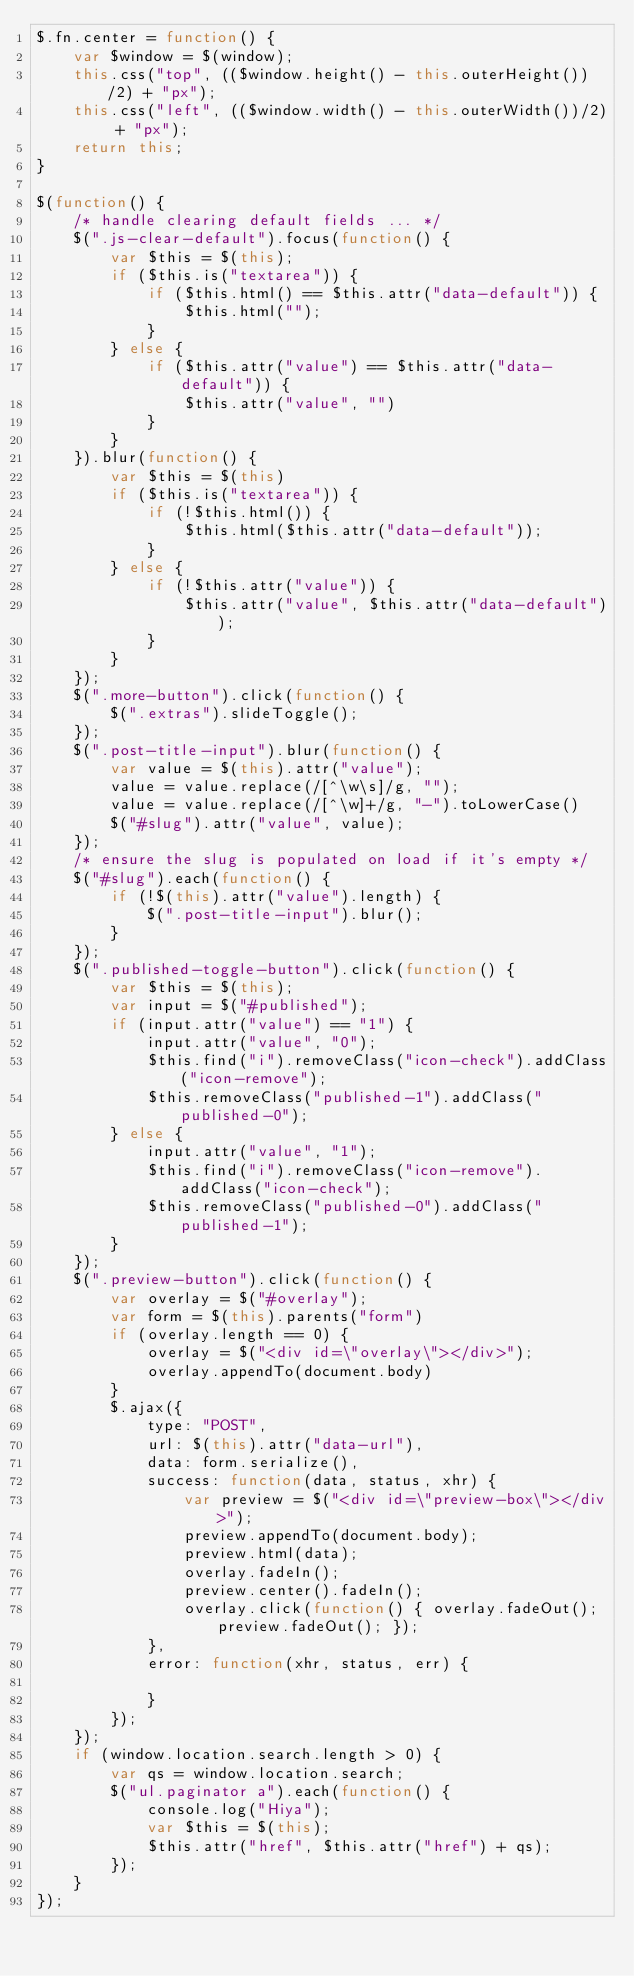<code> <loc_0><loc_0><loc_500><loc_500><_JavaScript_>$.fn.center = function() {
    var $window = $(window);
    this.css("top", (($window.height() - this.outerHeight())/2) + "px");
    this.css("left", (($window.width() - this.outerWidth())/2) + "px");
    return this;
}

$(function() {
    /* handle clearing default fields ... */
    $(".js-clear-default").focus(function() {
        var $this = $(this);
        if ($this.is("textarea")) {
            if ($this.html() == $this.attr("data-default")) {
                $this.html("");
            }
        } else {
            if ($this.attr("value") == $this.attr("data-default")) {
                $this.attr("value", "")
            }
        }
    }).blur(function() {
        var $this = $(this)
        if ($this.is("textarea")) {
            if (!$this.html()) {
                $this.html($this.attr("data-default"));
            }
        } else {
            if (!$this.attr("value")) {
                $this.attr("value", $this.attr("data-default"));
            }
        }
    });
    $(".more-button").click(function() {
        $(".extras").slideToggle();
    });
    $(".post-title-input").blur(function() {
        var value = $(this).attr("value");
        value = value.replace(/[^\w\s]/g, "");
        value = value.replace(/[^\w]+/g, "-").toLowerCase()
        $("#slug").attr("value", value);
    });
    /* ensure the slug is populated on load if it's empty */
    $("#slug").each(function() {
        if (!$(this).attr("value").length) {
            $(".post-title-input").blur();
        }
    });
    $(".published-toggle-button").click(function() {
        var $this = $(this);
        var input = $("#published");
        if (input.attr("value") == "1") {
            input.attr("value", "0");
            $this.find("i").removeClass("icon-check").addClass("icon-remove");
            $this.removeClass("published-1").addClass("published-0");
        } else {
            input.attr("value", "1");
            $this.find("i").removeClass("icon-remove").addClass("icon-check");
            $this.removeClass("published-0").addClass("published-1");
        }
    });
    $(".preview-button").click(function() {
        var overlay = $("#overlay");
        var form = $(this).parents("form")
        if (overlay.length == 0) {
            overlay = $("<div id=\"overlay\"></div>");
            overlay.appendTo(document.body)
        }
        $.ajax({
            type: "POST",
            url: $(this).attr("data-url"),
            data: form.serialize(),
            success: function(data, status, xhr) {
                var preview = $("<div id=\"preview-box\"></div>");
                preview.appendTo(document.body);
                preview.html(data);
                overlay.fadeIn();
                preview.center().fadeIn();
                overlay.click(function() { overlay.fadeOut(); preview.fadeOut(); });
            },
            error: function(xhr, status, err) {

            }
        });
    });
    if (window.location.search.length > 0) {
        var qs = window.location.search;
        $("ul.paginator a").each(function() {
            console.log("Hiya");
            var $this = $(this);
            $this.attr("href", $this.attr("href") + qs);
        });
    }
});



</code> 